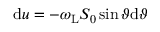<formula> <loc_0><loc_0><loc_500><loc_500>d u = - \omega _ { L } S _ { 0 } \sin \vartheta d \vartheta</formula> 